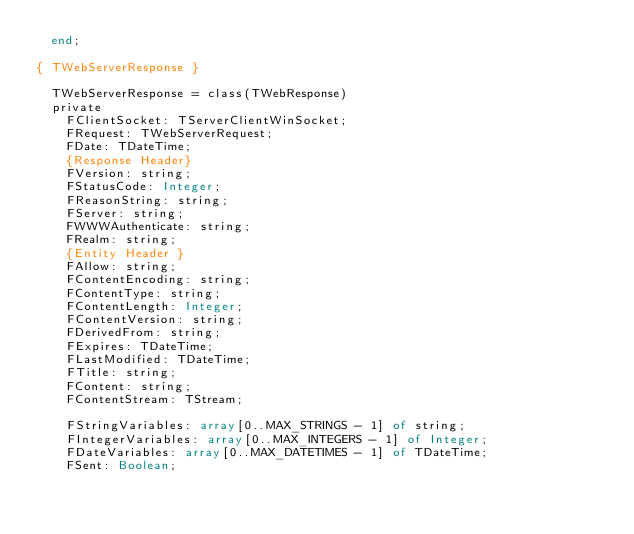<code> <loc_0><loc_0><loc_500><loc_500><_Pascal_>  end;

{ TWebServerResponse }

  TWebServerResponse = class(TWebResponse)
  private
    FClientSocket: TServerClientWinSocket;
    FRequest: TWebServerRequest;
    FDate: TDateTime;
    {Response Header}
    FVersion: string;
    FStatusCode: Integer;
    FReasonString: string;
    FServer: string;
    FWWWAuthenticate: string;
    FRealm: string;
    {Entity Header }
    FAllow: string;
    FContentEncoding: string;
    FContentType: string;
    FContentLength: Integer;
    FContentVersion: string;
    FDerivedFrom: string;
    FExpires: TDateTime;
    FLastModified: TDateTime;
    FTitle: string;
    FContent: string;
    FContentStream: TStream;

    FStringVariables: array[0..MAX_STRINGS - 1] of string;
    FIntegerVariables: array[0..MAX_INTEGERS - 1] of Integer;
    FDateVariables: array[0..MAX_DATETIMES - 1] of TDateTime;
    FSent: Boolean;</code> 